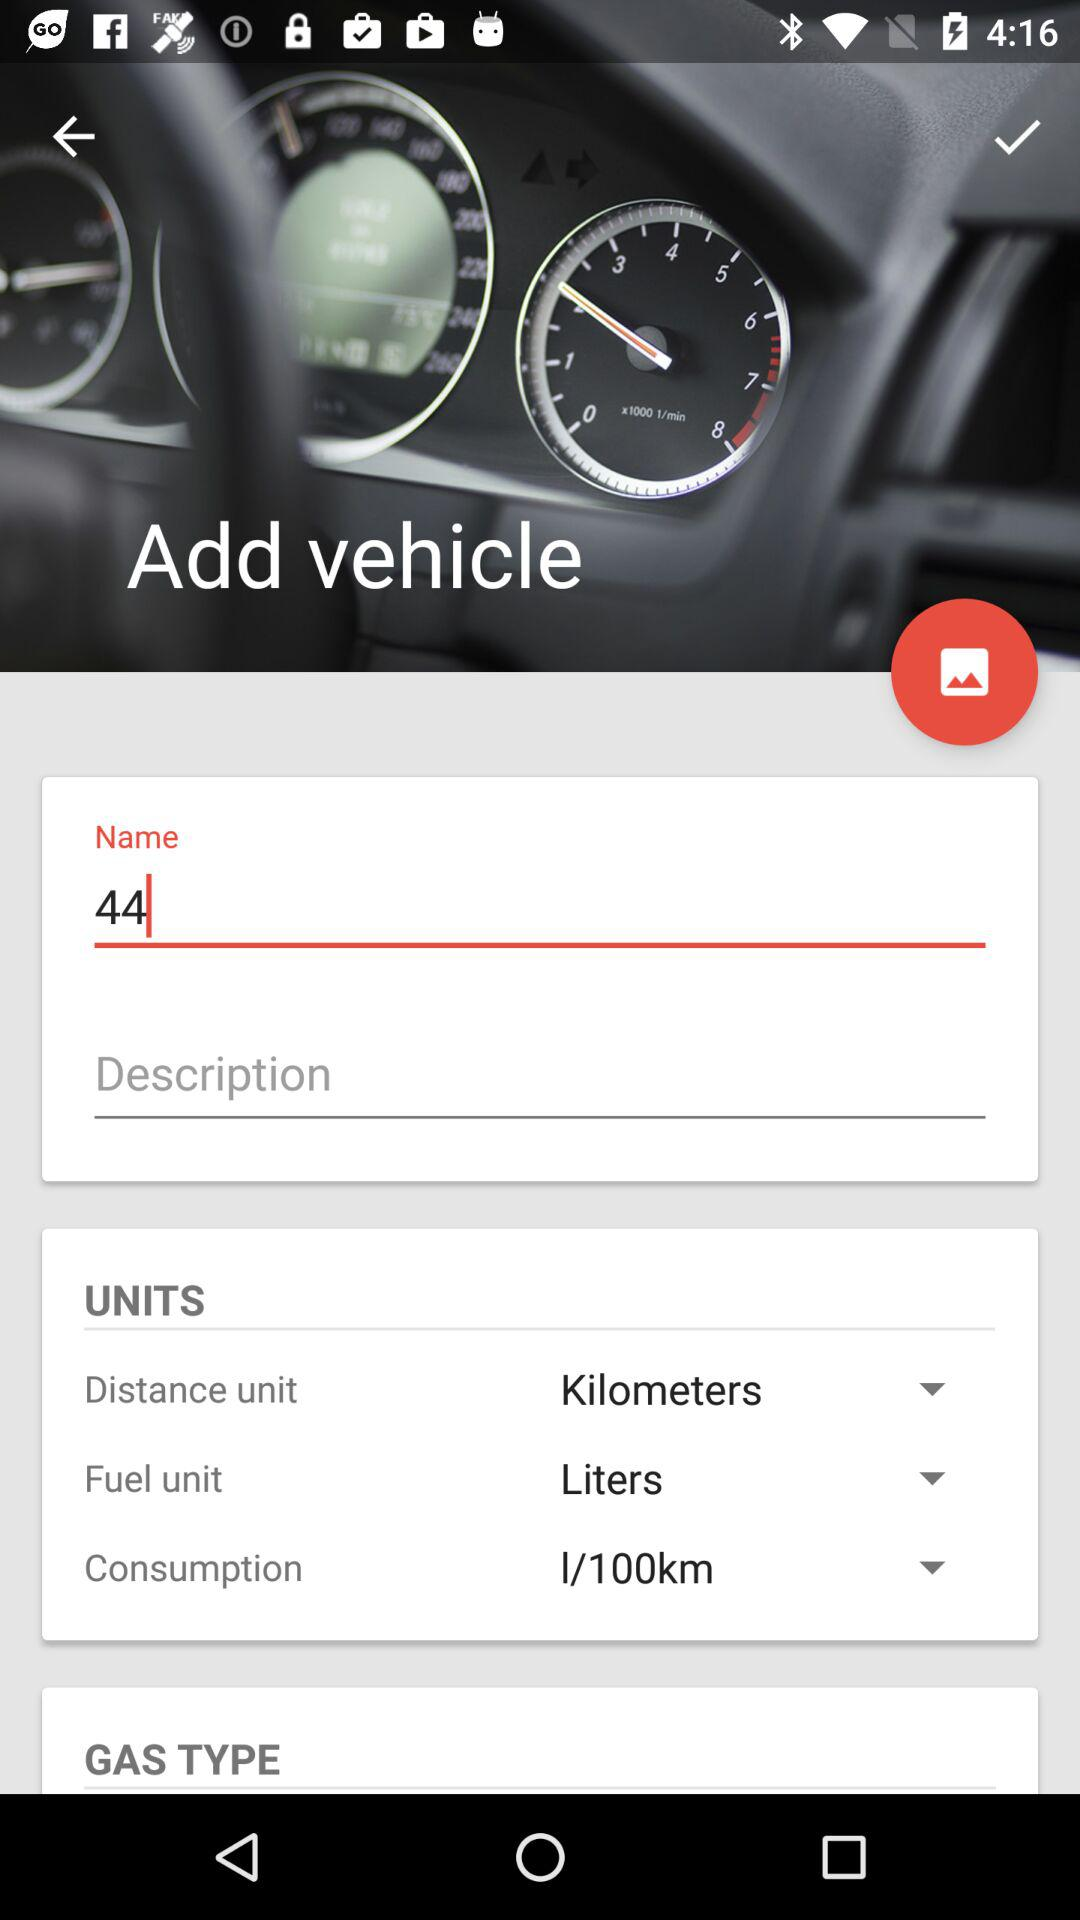What is the unit of distance? The unit of distance is kilometers. 